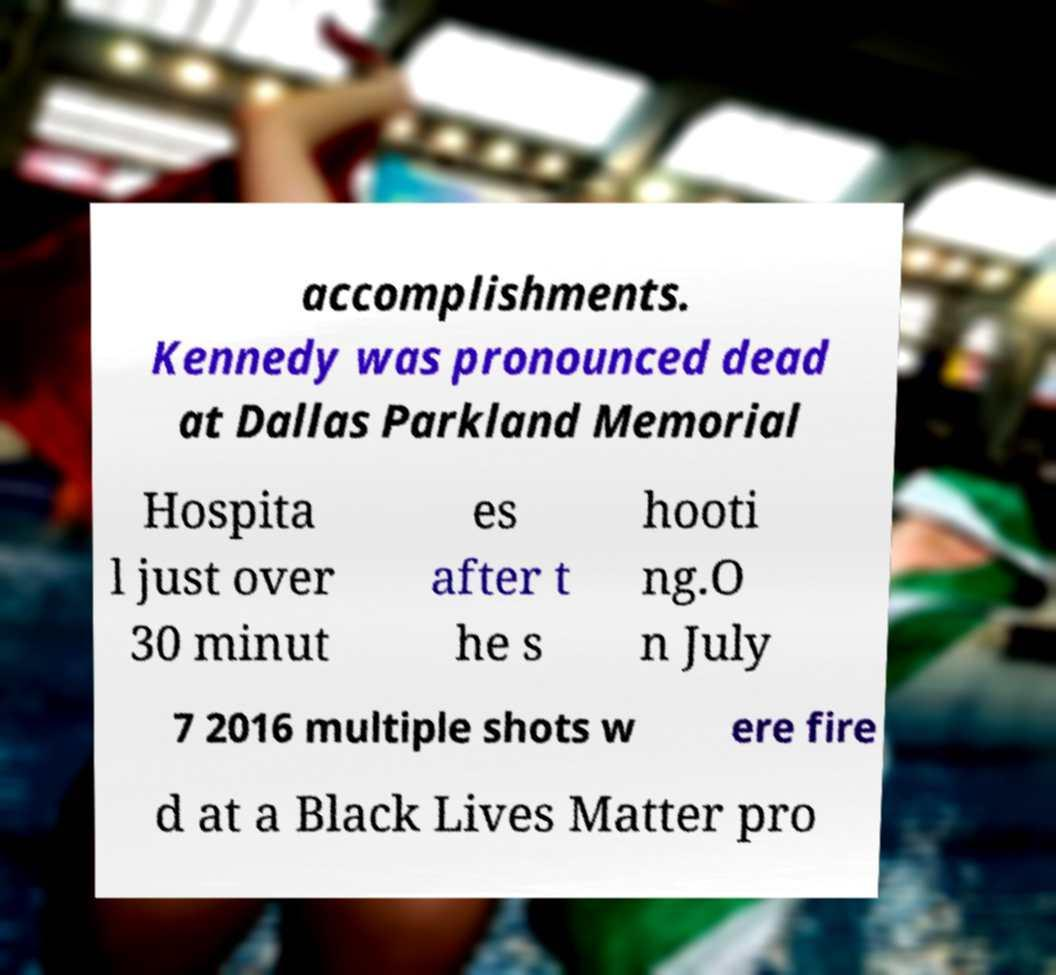What messages or text are displayed in this image? I need them in a readable, typed format. accomplishments. Kennedy was pronounced dead at Dallas Parkland Memorial Hospita l just over 30 minut es after t he s hooti ng.O n July 7 2016 multiple shots w ere fire d at a Black Lives Matter pro 